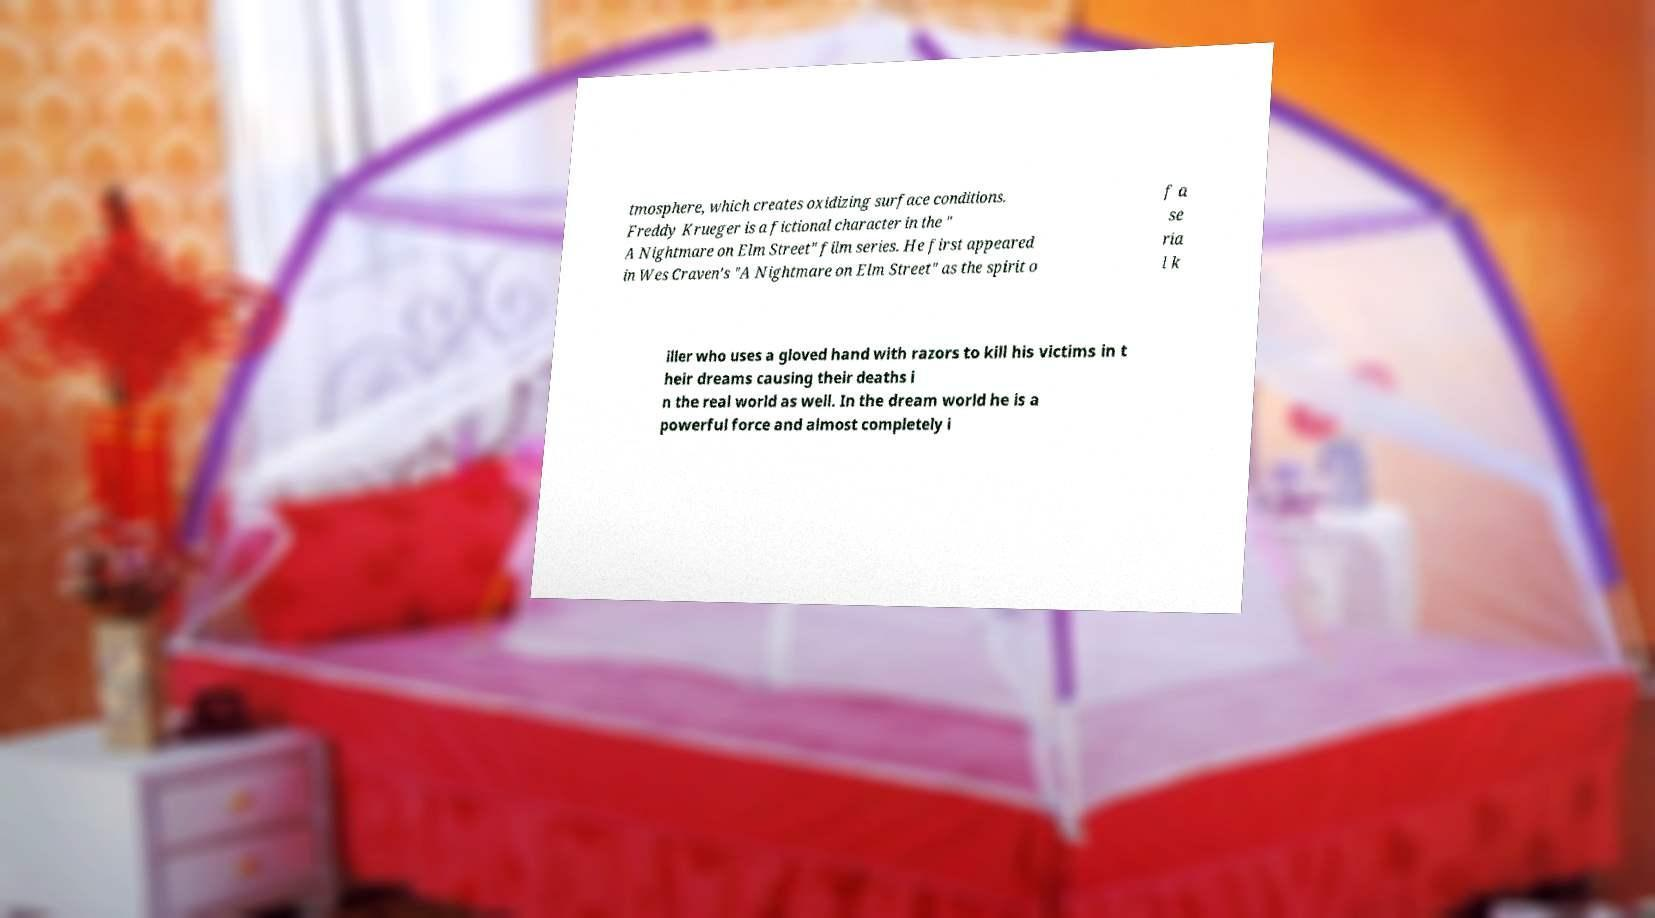I need the written content from this picture converted into text. Can you do that? tmosphere, which creates oxidizing surface conditions. Freddy Krueger is a fictional character in the " A Nightmare on Elm Street" film series. He first appeared in Wes Craven's "A Nightmare on Elm Street" as the spirit o f a se ria l k iller who uses a gloved hand with razors to kill his victims in t heir dreams causing their deaths i n the real world as well. In the dream world he is a powerful force and almost completely i 